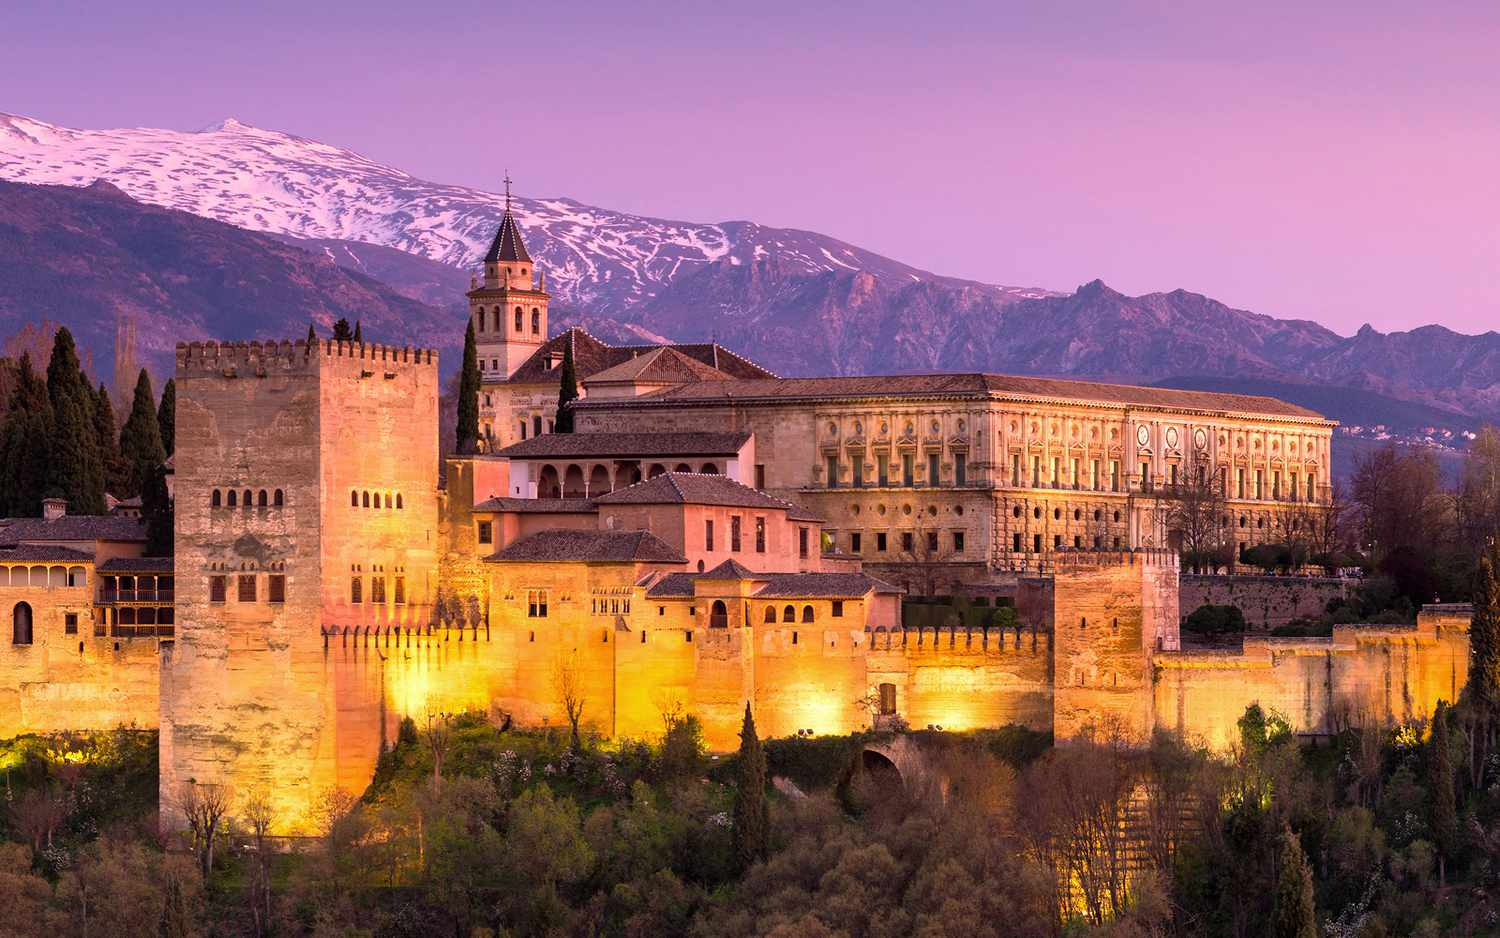What's happening in the scene? The image captures the grandeur of the Alhambra, a majestic palace and fortress complex nestled in Granada, Spain. The Alhambra, bathed in warm yellow lights, stands out against the backdrop of the Sierra Nevada mountain range. The mountains, under the cool blue and purple hues of the sky, add a sense of depth and scale to the scene. The image is taken from a slightly elevated perspective, offering a comprehensive view of the complex and its surroundings. The contrast between the illuminated buildings and the twilight sky creates a captivating visual spectacle, highlighting the architectural splendor of the Alhambra. 